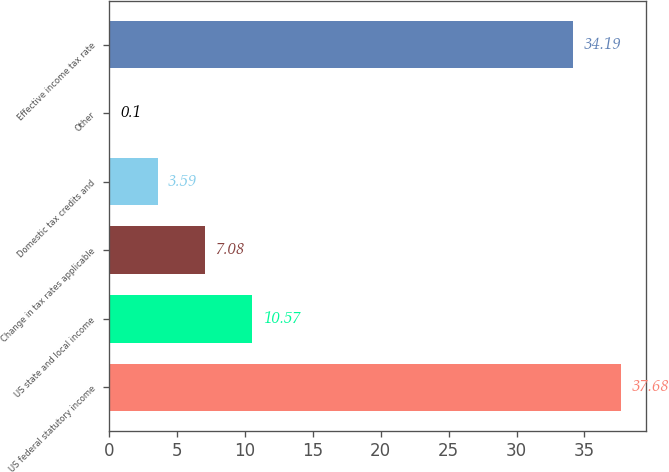Convert chart to OTSL. <chart><loc_0><loc_0><loc_500><loc_500><bar_chart><fcel>US federal statutory income<fcel>US state and local income<fcel>Change in tax rates applicable<fcel>Domestic tax credits and<fcel>Other<fcel>Effective income tax rate<nl><fcel>37.68<fcel>10.57<fcel>7.08<fcel>3.59<fcel>0.1<fcel>34.19<nl></chart> 